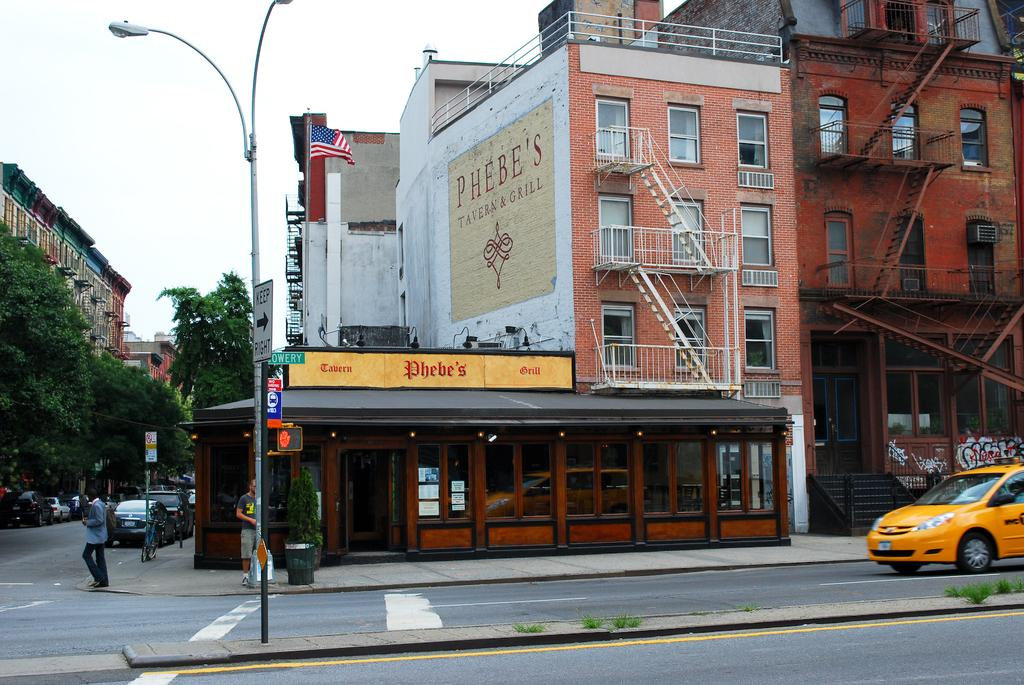<image>
Create a compact narrative representing the image presented. a store that is called Phebe's is outside in daytime 